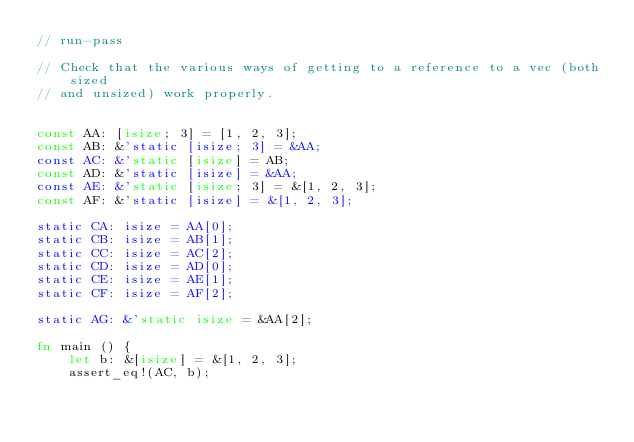<code> <loc_0><loc_0><loc_500><loc_500><_Rust_>// run-pass

// Check that the various ways of getting to a reference to a vec (both sized
// and unsized) work properly.


const AA: [isize; 3] = [1, 2, 3];
const AB: &'static [isize; 3] = &AA;
const AC: &'static [isize] = AB;
const AD: &'static [isize] = &AA;
const AE: &'static [isize; 3] = &[1, 2, 3];
const AF: &'static [isize] = &[1, 2, 3];

static CA: isize = AA[0];
static CB: isize = AB[1];
static CC: isize = AC[2];
static CD: isize = AD[0];
static CE: isize = AE[1];
static CF: isize = AF[2];

static AG: &'static isize = &AA[2];

fn main () {
    let b: &[isize] = &[1, 2, 3];
    assert_eq!(AC, b);</code> 